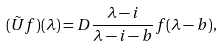<formula> <loc_0><loc_0><loc_500><loc_500>( \tilde { U } f ) ( \lambda ) = D \frac { \lambda - i } { \lambda - i - b } f ( \lambda - b ) ,</formula> 